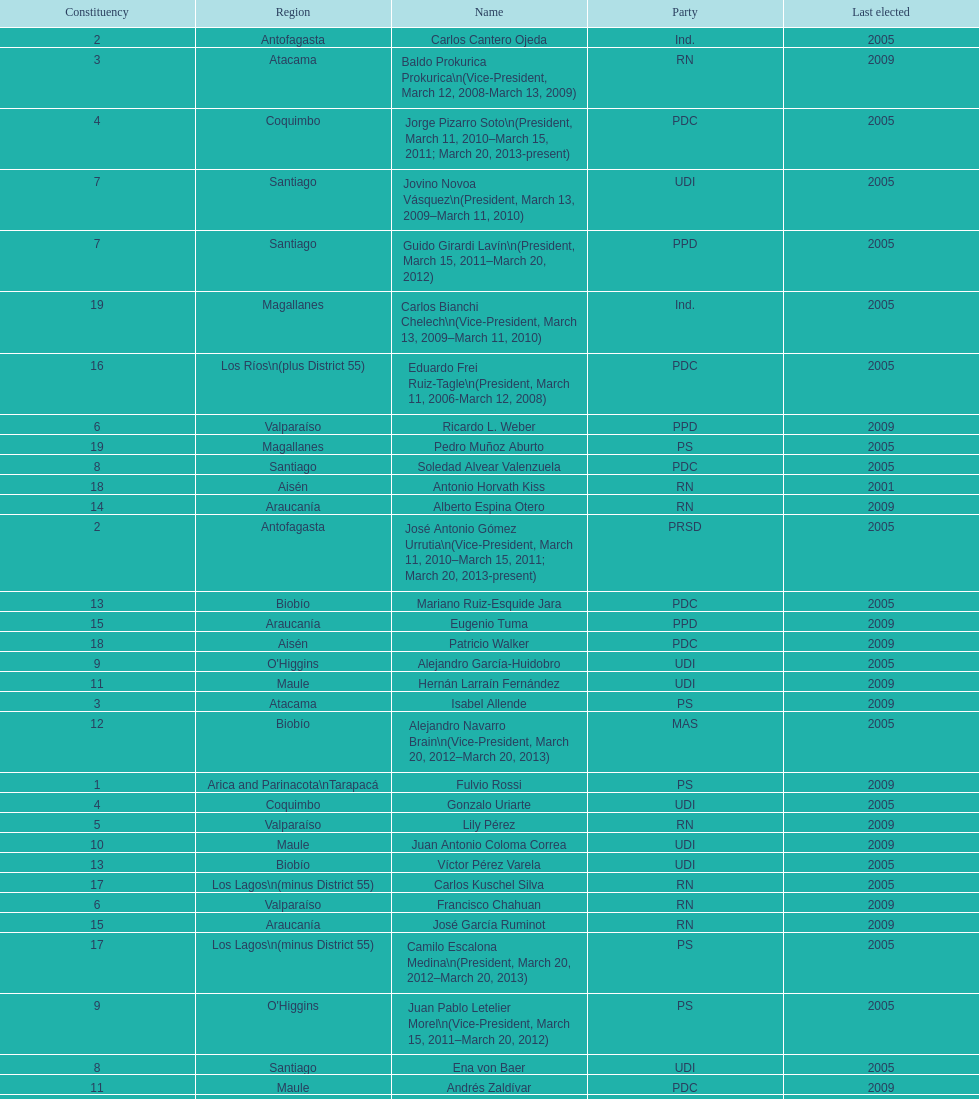How long was baldo prokurica prokurica vice-president? 1 year. 